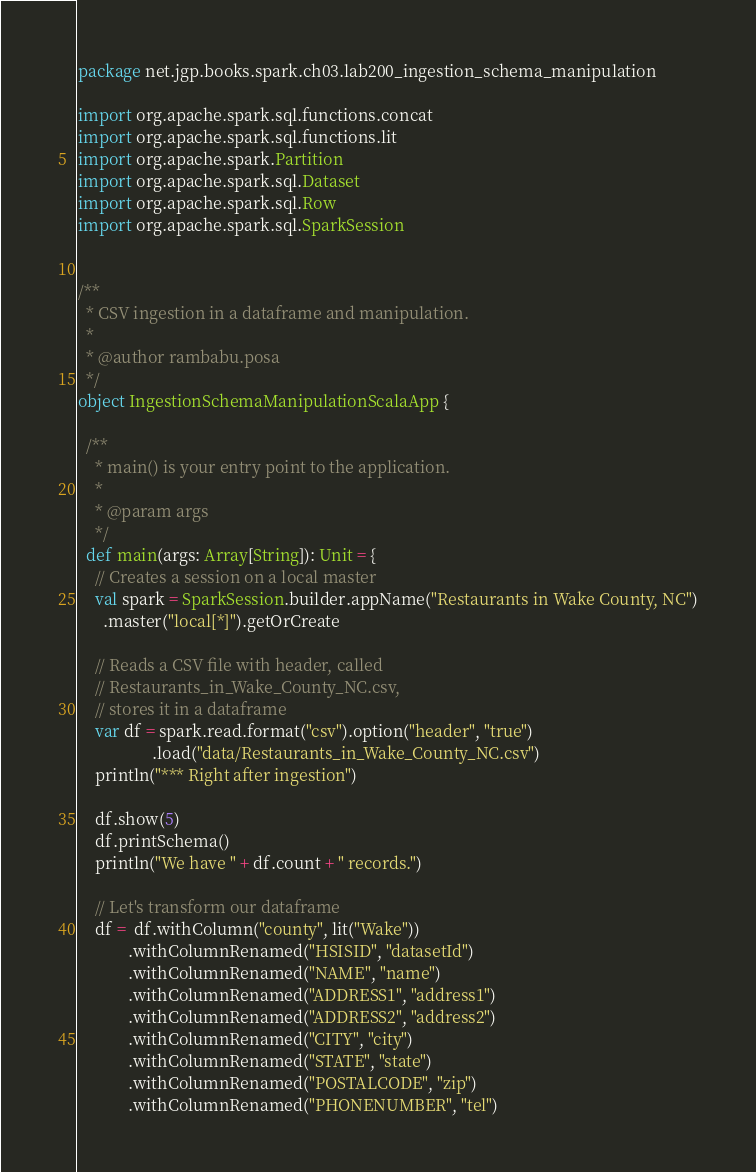Convert code to text. <code><loc_0><loc_0><loc_500><loc_500><_Scala_>package net.jgp.books.spark.ch03.lab200_ingestion_schema_manipulation

import org.apache.spark.sql.functions.concat
import org.apache.spark.sql.functions.lit
import org.apache.spark.Partition
import org.apache.spark.sql.Dataset
import org.apache.spark.sql.Row
import org.apache.spark.sql.SparkSession


/**
  * CSV ingestion in a dataframe and manipulation.
  *
  * @author rambabu.posa
  */
object IngestionSchemaManipulationScalaApp {

  /**
    * main() is your entry point to the application.
    *
    * @param args
    */
  def main(args: Array[String]): Unit = {
    // Creates a session on a local master
    val spark = SparkSession.builder.appName("Restaurants in Wake County, NC")
      .master("local[*]").getOrCreate

    // Reads a CSV file with header, called
    // Restaurants_in_Wake_County_NC.csv,
    // stores it in a dataframe
    var df = spark.read.format("csv").option("header", "true")
                  .load("data/Restaurants_in_Wake_County_NC.csv")
    println("*** Right after ingestion")

    df.show(5)
    df.printSchema()
    println("We have " + df.count + " records.")

    // Let's transform our dataframe
    df =  df.withColumn("county", lit("Wake"))
            .withColumnRenamed("HSISID", "datasetId")
            .withColumnRenamed("NAME", "name")
            .withColumnRenamed("ADDRESS1", "address1")
            .withColumnRenamed("ADDRESS2", "address2")
            .withColumnRenamed("CITY", "city")
            .withColumnRenamed("STATE", "state")
            .withColumnRenamed("POSTALCODE", "zip")
            .withColumnRenamed("PHONENUMBER", "tel")</code> 